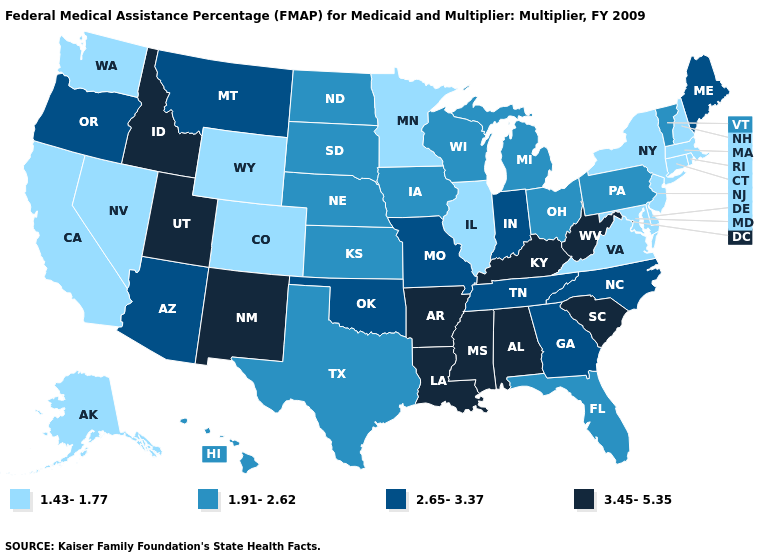Name the states that have a value in the range 2.65-3.37?
Concise answer only. Arizona, Georgia, Indiana, Maine, Missouri, Montana, North Carolina, Oklahoma, Oregon, Tennessee. What is the value of New Jersey?
Answer briefly. 1.43-1.77. What is the value of North Carolina?
Short answer required. 2.65-3.37. Which states have the lowest value in the West?
Give a very brief answer. Alaska, California, Colorado, Nevada, Washington, Wyoming. What is the lowest value in the South?
Be succinct. 1.43-1.77. Which states have the lowest value in the USA?
Quick response, please. Alaska, California, Colorado, Connecticut, Delaware, Illinois, Maryland, Massachusetts, Minnesota, Nevada, New Hampshire, New Jersey, New York, Rhode Island, Virginia, Washington, Wyoming. What is the lowest value in states that border New York?
Keep it brief. 1.43-1.77. Does Connecticut have the highest value in the Northeast?
Short answer required. No. Does Indiana have the highest value in the MidWest?
Quick response, please. Yes. Among the states that border North Carolina , which have the lowest value?
Write a very short answer. Virginia. What is the lowest value in the Northeast?
Answer briefly. 1.43-1.77. Name the states that have a value in the range 2.65-3.37?
Answer briefly. Arizona, Georgia, Indiana, Maine, Missouri, Montana, North Carolina, Oklahoma, Oregon, Tennessee. Name the states that have a value in the range 1.43-1.77?
Write a very short answer. Alaska, California, Colorado, Connecticut, Delaware, Illinois, Maryland, Massachusetts, Minnesota, Nevada, New Hampshire, New Jersey, New York, Rhode Island, Virginia, Washington, Wyoming. How many symbols are there in the legend?
Give a very brief answer. 4. 